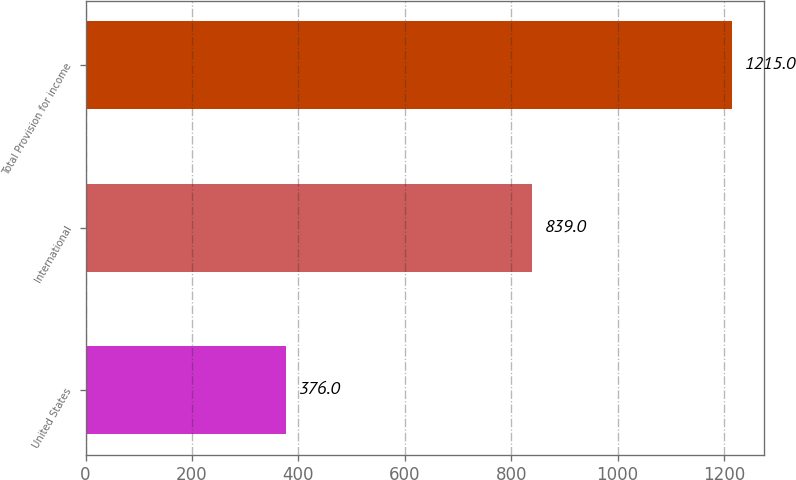<chart> <loc_0><loc_0><loc_500><loc_500><bar_chart><fcel>United States<fcel>International<fcel>Total Provision for income<nl><fcel>376<fcel>839<fcel>1215<nl></chart> 